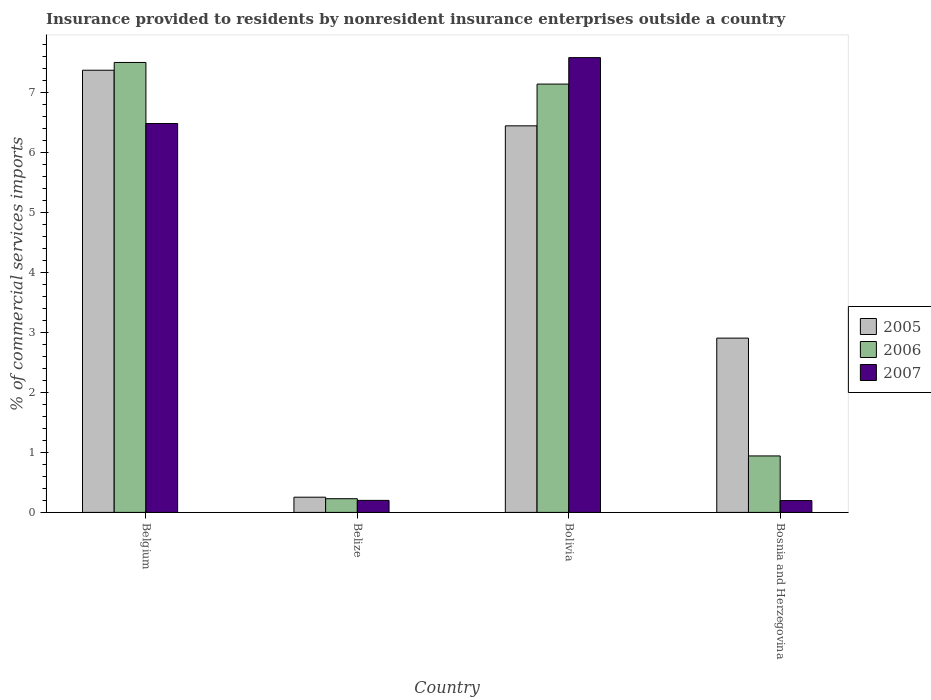How many different coloured bars are there?
Keep it short and to the point. 3. How many groups of bars are there?
Ensure brevity in your answer.  4. How many bars are there on the 2nd tick from the left?
Offer a very short reply. 3. What is the label of the 4th group of bars from the left?
Your response must be concise. Bosnia and Herzegovina. What is the Insurance provided to residents in 2006 in Belize?
Keep it short and to the point. 0.23. Across all countries, what is the maximum Insurance provided to residents in 2006?
Keep it short and to the point. 7.51. Across all countries, what is the minimum Insurance provided to residents in 2007?
Give a very brief answer. 0.2. In which country was the Insurance provided to residents in 2007 minimum?
Give a very brief answer. Bosnia and Herzegovina. What is the total Insurance provided to residents in 2007 in the graph?
Make the answer very short. 14.48. What is the difference between the Insurance provided to residents in 2005 in Belgium and that in Bolivia?
Ensure brevity in your answer.  0.93. What is the difference between the Insurance provided to residents in 2006 in Bosnia and Herzegovina and the Insurance provided to residents in 2007 in Bolivia?
Your answer should be compact. -6.65. What is the average Insurance provided to residents in 2006 per country?
Offer a terse response. 3.96. What is the difference between the Insurance provided to residents of/in 2007 and Insurance provided to residents of/in 2005 in Belize?
Provide a succinct answer. -0.05. In how many countries, is the Insurance provided to residents in 2006 greater than 1.2 %?
Provide a short and direct response. 2. What is the ratio of the Insurance provided to residents in 2007 in Belize to that in Bolivia?
Provide a succinct answer. 0.03. Is the difference between the Insurance provided to residents in 2007 in Belgium and Bolivia greater than the difference between the Insurance provided to residents in 2005 in Belgium and Bolivia?
Your answer should be compact. No. What is the difference between the highest and the second highest Insurance provided to residents in 2007?
Offer a terse response. -6.29. What is the difference between the highest and the lowest Insurance provided to residents in 2006?
Your answer should be very brief. 7.28. What does the 2nd bar from the left in Bosnia and Herzegovina represents?
Your response must be concise. 2006. Are all the bars in the graph horizontal?
Give a very brief answer. No. What is the difference between two consecutive major ticks on the Y-axis?
Provide a short and direct response. 1. Are the values on the major ticks of Y-axis written in scientific E-notation?
Your answer should be compact. No. Does the graph contain grids?
Keep it short and to the point. No. How are the legend labels stacked?
Make the answer very short. Vertical. What is the title of the graph?
Give a very brief answer. Insurance provided to residents by nonresident insurance enterprises outside a country. Does "2015" appear as one of the legend labels in the graph?
Provide a succinct answer. No. What is the label or title of the Y-axis?
Make the answer very short. % of commercial services imports. What is the % of commercial services imports in 2005 in Belgium?
Give a very brief answer. 7.38. What is the % of commercial services imports in 2006 in Belgium?
Your answer should be very brief. 7.51. What is the % of commercial services imports in 2007 in Belgium?
Offer a terse response. 6.49. What is the % of commercial services imports in 2005 in Belize?
Your response must be concise. 0.25. What is the % of commercial services imports in 2006 in Belize?
Provide a succinct answer. 0.23. What is the % of commercial services imports of 2007 in Belize?
Offer a very short reply. 0.2. What is the % of commercial services imports of 2005 in Bolivia?
Your answer should be compact. 6.45. What is the % of commercial services imports in 2006 in Bolivia?
Offer a terse response. 7.15. What is the % of commercial services imports of 2007 in Bolivia?
Give a very brief answer. 7.59. What is the % of commercial services imports in 2005 in Bosnia and Herzegovina?
Offer a terse response. 2.91. What is the % of commercial services imports of 2006 in Bosnia and Herzegovina?
Provide a short and direct response. 0.94. What is the % of commercial services imports in 2007 in Bosnia and Herzegovina?
Give a very brief answer. 0.2. Across all countries, what is the maximum % of commercial services imports in 2005?
Your answer should be very brief. 7.38. Across all countries, what is the maximum % of commercial services imports in 2006?
Ensure brevity in your answer.  7.51. Across all countries, what is the maximum % of commercial services imports of 2007?
Give a very brief answer. 7.59. Across all countries, what is the minimum % of commercial services imports of 2005?
Give a very brief answer. 0.25. Across all countries, what is the minimum % of commercial services imports in 2006?
Ensure brevity in your answer.  0.23. Across all countries, what is the minimum % of commercial services imports in 2007?
Make the answer very short. 0.2. What is the total % of commercial services imports in 2005 in the graph?
Offer a very short reply. 16.99. What is the total % of commercial services imports in 2006 in the graph?
Offer a terse response. 15.83. What is the total % of commercial services imports in 2007 in the graph?
Make the answer very short. 14.48. What is the difference between the % of commercial services imports in 2005 in Belgium and that in Belize?
Offer a very short reply. 7.12. What is the difference between the % of commercial services imports in 2006 in Belgium and that in Belize?
Provide a short and direct response. 7.28. What is the difference between the % of commercial services imports of 2007 in Belgium and that in Belize?
Ensure brevity in your answer.  6.29. What is the difference between the % of commercial services imports of 2005 in Belgium and that in Bolivia?
Provide a succinct answer. 0.93. What is the difference between the % of commercial services imports in 2006 in Belgium and that in Bolivia?
Your answer should be very brief. 0.36. What is the difference between the % of commercial services imports in 2007 in Belgium and that in Bolivia?
Offer a very short reply. -1.1. What is the difference between the % of commercial services imports of 2005 in Belgium and that in Bosnia and Herzegovina?
Offer a very short reply. 4.47. What is the difference between the % of commercial services imports of 2006 in Belgium and that in Bosnia and Herzegovina?
Your response must be concise. 6.57. What is the difference between the % of commercial services imports of 2007 in Belgium and that in Bosnia and Herzegovina?
Give a very brief answer. 6.29. What is the difference between the % of commercial services imports of 2005 in Belize and that in Bolivia?
Ensure brevity in your answer.  -6.2. What is the difference between the % of commercial services imports in 2006 in Belize and that in Bolivia?
Your response must be concise. -6.92. What is the difference between the % of commercial services imports in 2007 in Belize and that in Bolivia?
Make the answer very short. -7.39. What is the difference between the % of commercial services imports in 2005 in Belize and that in Bosnia and Herzegovina?
Provide a succinct answer. -2.65. What is the difference between the % of commercial services imports in 2006 in Belize and that in Bosnia and Herzegovina?
Your answer should be very brief. -0.71. What is the difference between the % of commercial services imports in 2007 in Belize and that in Bosnia and Herzegovina?
Give a very brief answer. 0. What is the difference between the % of commercial services imports in 2005 in Bolivia and that in Bosnia and Herzegovina?
Your answer should be very brief. 3.54. What is the difference between the % of commercial services imports in 2006 in Bolivia and that in Bosnia and Herzegovina?
Give a very brief answer. 6.21. What is the difference between the % of commercial services imports in 2007 in Bolivia and that in Bosnia and Herzegovina?
Offer a terse response. 7.39. What is the difference between the % of commercial services imports in 2005 in Belgium and the % of commercial services imports in 2006 in Belize?
Keep it short and to the point. 7.15. What is the difference between the % of commercial services imports in 2005 in Belgium and the % of commercial services imports in 2007 in Belize?
Offer a terse response. 7.18. What is the difference between the % of commercial services imports in 2006 in Belgium and the % of commercial services imports in 2007 in Belize?
Provide a short and direct response. 7.31. What is the difference between the % of commercial services imports in 2005 in Belgium and the % of commercial services imports in 2006 in Bolivia?
Provide a short and direct response. 0.23. What is the difference between the % of commercial services imports of 2005 in Belgium and the % of commercial services imports of 2007 in Bolivia?
Your response must be concise. -0.21. What is the difference between the % of commercial services imports in 2006 in Belgium and the % of commercial services imports in 2007 in Bolivia?
Offer a very short reply. -0.08. What is the difference between the % of commercial services imports in 2005 in Belgium and the % of commercial services imports in 2006 in Bosnia and Herzegovina?
Your response must be concise. 6.44. What is the difference between the % of commercial services imports in 2005 in Belgium and the % of commercial services imports in 2007 in Bosnia and Herzegovina?
Make the answer very short. 7.18. What is the difference between the % of commercial services imports in 2006 in Belgium and the % of commercial services imports in 2007 in Bosnia and Herzegovina?
Provide a succinct answer. 7.31. What is the difference between the % of commercial services imports of 2005 in Belize and the % of commercial services imports of 2006 in Bolivia?
Give a very brief answer. -6.89. What is the difference between the % of commercial services imports of 2005 in Belize and the % of commercial services imports of 2007 in Bolivia?
Give a very brief answer. -7.34. What is the difference between the % of commercial services imports in 2006 in Belize and the % of commercial services imports in 2007 in Bolivia?
Ensure brevity in your answer.  -7.36. What is the difference between the % of commercial services imports of 2005 in Belize and the % of commercial services imports of 2006 in Bosnia and Herzegovina?
Ensure brevity in your answer.  -0.69. What is the difference between the % of commercial services imports of 2005 in Belize and the % of commercial services imports of 2007 in Bosnia and Herzegovina?
Provide a short and direct response. 0.06. What is the difference between the % of commercial services imports in 2006 in Belize and the % of commercial services imports in 2007 in Bosnia and Herzegovina?
Offer a terse response. 0.03. What is the difference between the % of commercial services imports of 2005 in Bolivia and the % of commercial services imports of 2006 in Bosnia and Herzegovina?
Provide a short and direct response. 5.51. What is the difference between the % of commercial services imports in 2005 in Bolivia and the % of commercial services imports in 2007 in Bosnia and Herzegovina?
Your answer should be very brief. 6.25. What is the difference between the % of commercial services imports in 2006 in Bolivia and the % of commercial services imports in 2007 in Bosnia and Herzegovina?
Provide a short and direct response. 6.95. What is the average % of commercial services imports of 2005 per country?
Keep it short and to the point. 4.25. What is the average % of commercial services imports of 2006 per country?
Your response must be concise. 3.96. What is the average % of commercial services imports in 2007 per country?
Your response must be concise. 3.62. What is the difference between the % of commercial services imports in 2005 and % of commercial services imports in 2006 in Belgium?
Keep it short and to the point. -0.13. What is the difference between the % of commercial services imports of 2005 and % of commercial services imports of 2007 in Belgium?
Provide a succinct answer. 0.89. What is the difference between the % of commercial services imports in 2006 and % of commercial services imports in 2007 in Belgium?
Your answer should be very brief. 1.02. What is the difference between the % of commercial services imports of 2005 and % of commercial services imports of 2006 in Belize?
Provide a succinct answer. 0.03. What is the difference between the % of commercial services imports of 2005 and % of commercial services imports of 2007 in Belize?
Provide a succinct answer. 0.05. What is the difference between the % of commercial services imports in 2006 and % of commercial services imports in 2007 in Belize?
Keep it short and to the point. 0.03. What is the difference between the % of commercial services imports in 2005 and % of commercial services imports in 2006 in Bolivia?
Offer a very short reply. -0.7. What is the difference between the % of commercial services imports of 2005 and % of commercial services imports of 2007 in Bolivia?
Give a very brief answer. -1.14. What is the difference between the % of commercial services imports of 2006 and % of commercial services imports of 2007 in Bolivia?
Provide a succinct answer. -0.44. What is the difference between the % of commercial services imports of 2005 and % of commercial services imports of 2006 in Bosnia and Herzegovina?
Offer a very short reply. 1.97. What is the difference between the % of commercial services imports of 2005 and % of commercial services imports of 2007 in Bosnia and Herzegovina?
Offer a terse response. 2.71. What is the difference between the % of commercial services imports in 2006 and % of commercial services imports in 2007 in Bosnia and Herzegovina?
Ensure brevity in your answer.  0.74. What is the ratio of the % of commercial services imports in 2005 in Belgium to that in Belize?
Keep it short and to the point. 29.09. What is the ratio of the % of commercial services imports in 2006 in Belgium to that in Belize?
Your response must be concise. 32.89. What is the ratio of the % of commercial services imports in 2007 in Belgium to that in Belize?
Your answer should be very brief. 32.36. What is the ratio of the % of commercial services imports in 2005 in Belgium to that in Bolivia?
Provide a short and direct response. 1.14. What is the ratio of the % of commercial services imports in 2006 in Belgium to that in Bolivia?
Offer a very short reply. 1.05. What is the ratio of the % of commercial services imports in 2007 in Belgium to that in Bolivia?
Provide a short and direct response. 0.86. What is the ratio of the % of commercial services imports of 2005 in Belgium to that in Bosnia and Herzegovina?
Your answer should be very brief. 2.54. What is the ratio of the % of commercial services imports in 2006 in Belgium to that in Bosnia and Herzegovina?
Your answer should be very brief. 7.97. What is the ratio of the % of commercial services imports in 2007 in Belgium to that in Bosnia and Herzegovina?
Provide a short and direct response. 32.86. What is the ratio of the % of commercial services imports in 2005 in Belize to that in Bolivia?
Keep it short and to the point. 0.04. What is the ratio of the % of commercial services imports of 2006 in Belize to that in Bolivia?
Offer a terse response. 0.03. What is the ratio of the % of commercial services imports in 2007 in Belize to that in Bolivia?
Your response must be concise. 0.03. What is the ratio of the % of commercial services imports of 2005 in Belize to that in Bosnia and Herzegovina?
Your answer should be compact. 0.09. What is the ratio of the % of commercial services imports of 2006 in Belize to that in Bosnia and Herzegovina?
Provide a succinct answer. 0.24. What is the ratio of the % of commercial services imports of 2007 in Belize to that in Bosnia and Herzegovina?
Your answer should be very brief. 1.02. What is the ratio of the % of commercial services imports in 2005 in Bolivia to that in Bosnia and Herzegovina?
Offer a very short reply. 2.22. What is the ratio of the % of commercial services imports of 2006 in Bolivia to that in Bosnia and Herzegovina?
Your response must be concise. 7.58. What is the ratio of the % of commercial services imports of 2007 in Bolivia to that in Bosnia and Herzegovina?
Offer a very short reply. 38.43. What is the difference between the highest and the second highest % of commercial services imports in 2005?
Your response must be concise. 0.93. What is the difference between the highest and the second highest % of commercial services imports of 2006?
Offer a very short reply. 0.36. What is the difference between the highest and the second highest % of commercial services imports of 2007?
Your response must be concise. 1.1. What is the difference between the highest and the lowest % of commercial services imports of 2005?
Give a very brief answer. 7.12. What is the difference between the highest and the lowest % of commercial services imports of 2006?
Keep it short and to the point. 7.28. What is the difference between the highest and the lowest % of commercial services imports in 2007?
Your answer should be very brief. 7.39. 